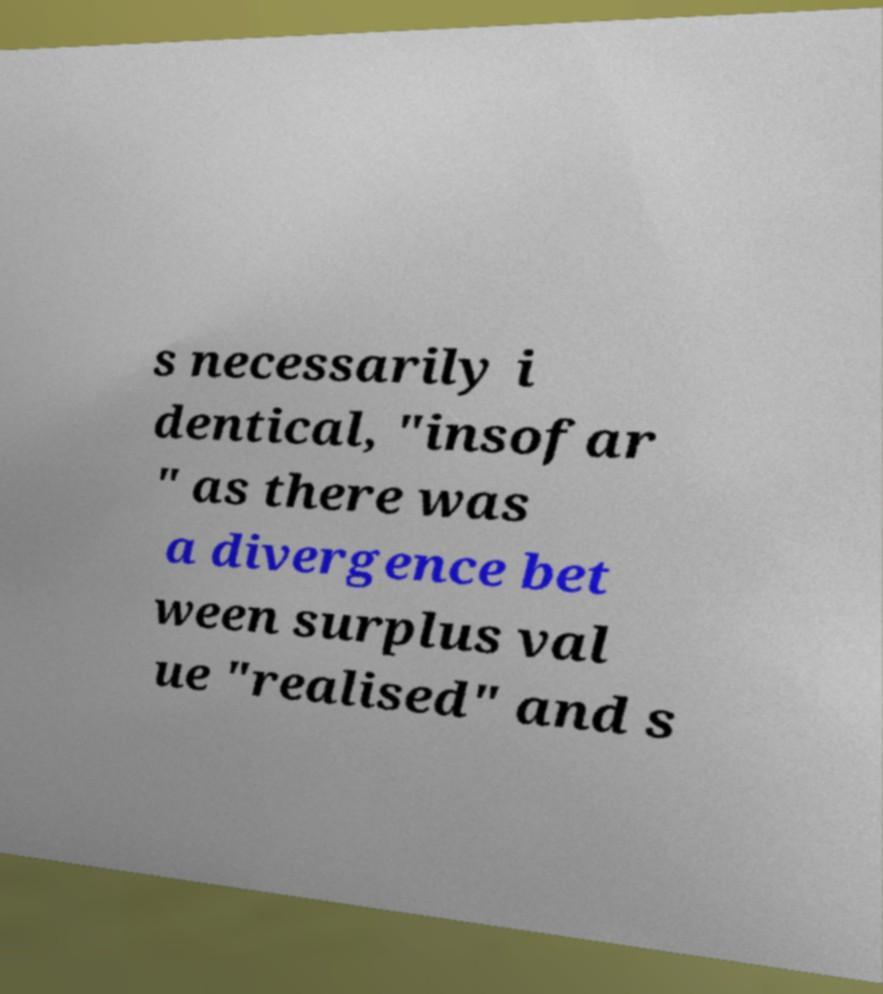There's text embedded in this image that I need extracted. Can you transcribe it verbatim? s necessarily i dentical, "insofar " as there was a divergence bet ween surplus val ue "realised" and s 